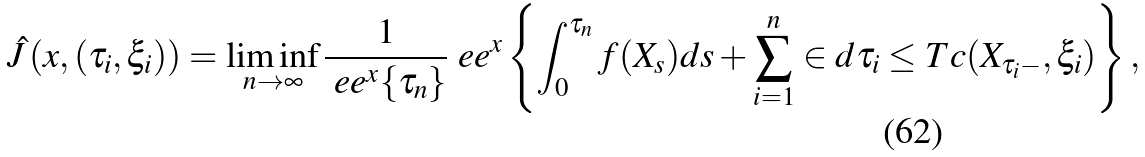Convert formula to latex. <formula><loc_0><loc_0><loc_500><loc_500>\hat { J } \left ( x , ( \tau _ { i } , \xi _ { i } ) \right ) = \liminf _ { n \to \infty } \frac { 1 } { \ e e ^ { x } \{ \tau _ { n } \} } \ e e ^ { x } \left \{ \int _ { 0 } ^ { \tau _ { n } } f ( X _ { s } ) d s + \sum _ { i = 1 } ^ { n } \in d { \tau _ { i } \leq T } c ( X _ { \tau _ { i } - } , \xi _ { i } ) \right \} ,</formula> 